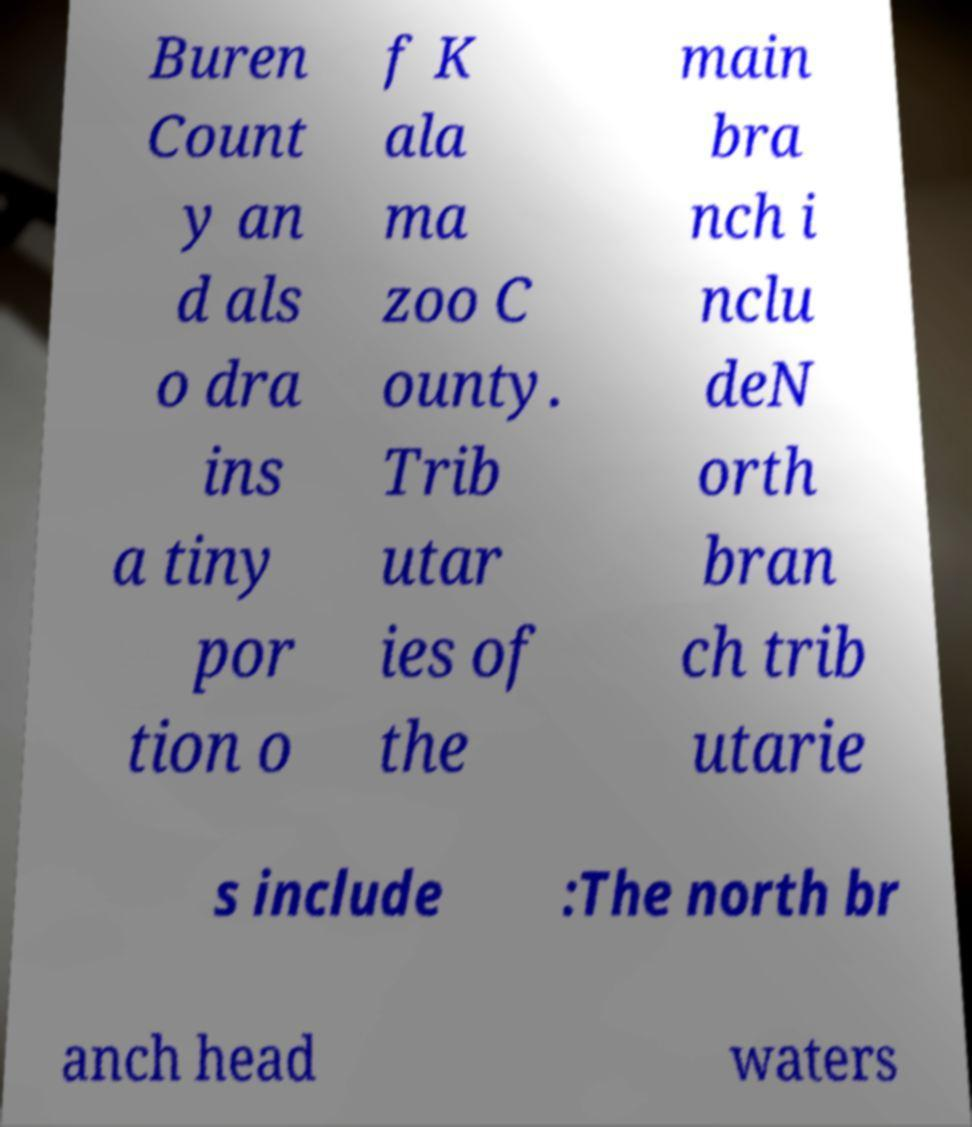Could you extract and type out the text from this image? Buren Count y an d als o dra ins a tiny por tion o f K ala ma zoo C ounty. Trib utar ies of the main bra nch i nclu deN orth bran ch trib utarie s include :The north br anch head waters 